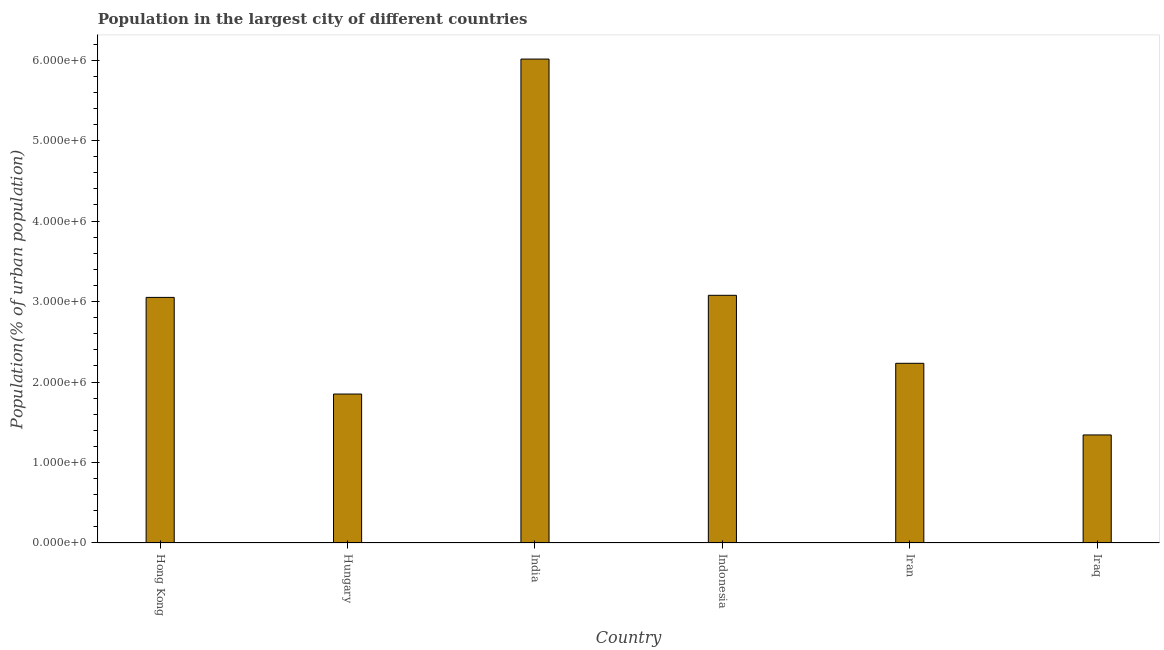What is the title of the graph?
Keep it short and to the point. Population in the largest city of different countries. What is the label or title of the Y-axis?
Provide a succinct answer. Population(% of urban population). What is the population in largest city in Iran?
Your answer should be very brief. 2.23e+06. Across all countries, what is the maximum population in largest city?
Keep it short and to the point. 6.01e+06. Across all countries, what is the minimum population in largest city?
Provide a succinct answer. 1.34e+06. In which country was the population in largest city minimum?
Provide a succinct answer. Iraq. What is the sum of the population in largest city?
Give a very brief answer. 1.76e+07. What is the difference between the population in largest city in India and Indonesia?
Provide a short and direct response. 2.94e+06. What is the average population in largest city per country?
Provide a short and direct response. 2.93e+06. What is the median population in largest city?
Your answer should be compact. 2.64e+06. In how many countries, is the population in largest city greater than 2200000 %?
Provide a short and direct response. 4. What is the ratio of the population in largest city in Hong Kong to that in Iraq?
Offer a very short reply. 2.27. Is the population in largest city in Hungary less than that in India?
Keep it short and to the point. Yes. What is the difference between the highest and the second highest population in largest city?
Make the answer very short. 2.94e+06. Is the sum of the population in largest city in Hong Kong and India greater than the maximum population in largest city across all countries?
Your answer should be compact. Yes. What is the difference between the highest and the lowest population in largest city?
Provide a succinct answer. 4.67e+06. How many bars are there?
Ensure brevity in your answer.  6. How many countries are there in the graph?
Your answer should be compact. 6. Are the values on the major ticks of Y-axis written in scientific E-notation?
Offer a very short reply. Yes. What is the Population(% of urban population) of Hong Kong?
Ensure brevity in your answer.  3.05e+06. What is the Population(% of urban population) in Hungary?
Your answer should be compact. 1.85e+06. What is the Population(% of urban population) of India?
Your response must be concise. 6.01e+06. What is the Population(% of urban population) of Indonesia?
Provide a short and direct response. 3.08e+06. What is the Population(% of urban population) in Iran?
Offer a terse response. 2.23e+06. What is the Population(% of urban population) of Iraq?
Your answer should be very brief. 1.34e+06. What is the difference between the Population(% of urban population) in Hong Kong and Hungary?
Give a very brief answer. 1.20e+06. What is the difference between the Population(% of urban population) in Hong Kong and India?
Your answer should be very brief. -2.96e+06. What is the difference between the Population(% of urban population) in Hong Kong and Indonesia?
Keep it short and to the point. -2.61e+04. What is the difference between the Population(% of urban population) in Hong Kong and Iran?
Make the answer very short. 8.19e+05. What is the difference between the Population(% of urban population) in Hong Kong and Iraq?
Provide a short and direct response. 1.71e+06. What is the difference between the Population(% of urban population) in Hungary and India?
Make the answer very short. -4.16e+06. What is the difference between the Population(% of urban population) in Hungary and Indonesia?
Keep it short and to the point. -1.23e+06. What is the difference between the Population(% of urban population) in Hungary and Iran?
Offer a terse response. -3.82e+05. What is the difference between the Population(% of urban population) in Hungary and Iraq?
Your response must be concise. 5.08e+05. What is the difference between the Population(% of urban population) in India and Indonesia?
Make the answer very short. 2.94e+06. What is the difference between the Population(% of urban population) in India and Iran?
Provide a succinct answer. 3.78e+06. What is the difference between the Population(% of urban population) in India and Iraq?
Make the answer very short. 4.67e+06. What is the difference between the Population(% of urban population) in Indonesia and Iran?
Offer a very short reply. 8.45e+05. What is the difference between the Population(% of urban population) in Indonesia and Iraq?
Your answer should be very brief. 1.74e+06. What is the difference between the Population(% of urban population) in Iran and Iraq?
Your answer should be very brief. 8.90e+05. What is the ratio of the Population(% of urban population) in Hong Kong to that in Hungary?
Give a very brief answer. 1.65. What is the ratio of the Population(% of urban population) in Hong Kong to that in India?
Provide a succinct answer. 0.51. What is the ratio of the Population(% of urban population) in Hong Kong to that in Iran?
Provide a short and direct response. 1.37. What is the ratio of the Population(% of urban population) in Hong Kong to that in Iraq?
Offer a terse response. 2.27. What is the ratio of the Population(% of urban population) in Hungary to that in India?
Your response must be concise. 0.31. What is the ratio of the Population(% of urban population) in Hungary to that in Indonesia?
Your response must be concise. 0.6. What is the ratio of the Population(% of urban population) in Hungary to that in Iran?
Your response must be concise. 0.83. What is the ratio of the Population(% of urban population) in Hungary to that in Iraq?
Keep it short and to the point. 1.38. What is the ratio of the Population(% of urban population) in India to that in Indonesia?
Offer a very short reply. 1.95. What is the ratio of the Population(% of urban population) in India to that in Iran?
Your answer should be compact. 2.69. What is the ratio of the Population(% of urban population) in India to that in Iraq?
Offer a very short reply. 4.48. What is the ratio of the Population(% of urban population) in Indonesia to that in Iran?
Offer a very short reply. 1.38. What is the ratio of the Population(% of urban population) in Indonesia to that in Iraq?
Make the answer very short. 2.29. What is the ratio of the Population(% of urban population) in Iran to that in Iraq?
Offer a terse response. 1.66. 